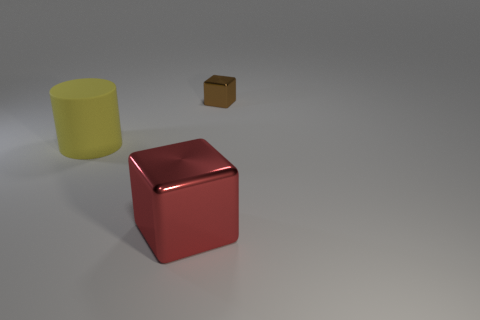Add 1 brown objects. How many objects exist? 4 Subtract all cylinders. How many objects are left? 2 Add 1 small shiny blocks. How many small shiny blocks are left? 2 Add 2 big yellow cylinders. How many big yellow cylinders exist? 3 Subtract 0 purple spheres. How many objects are left? 3 Subtract all cyan cylinders. Subtract all brown metallic cubes. How many objects are left? 2 